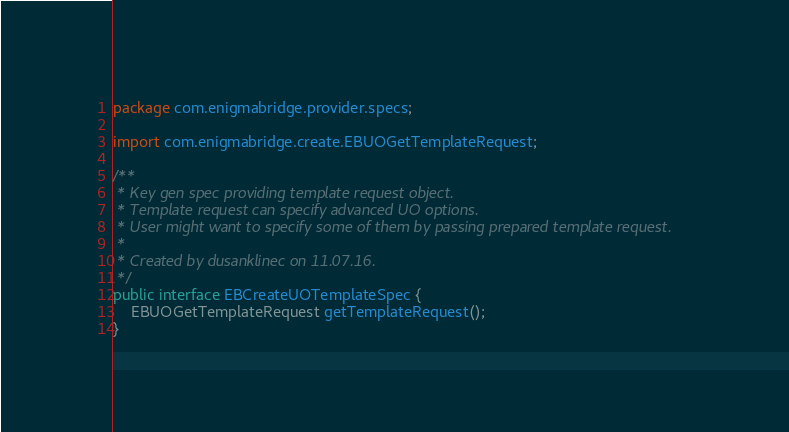<code> <loc_0><loc_0><loc_500><loc_500><_Java_>package com.enigmabridge.provider.specs;

import com.enigmabridge.create.EBUOGetTemplateRequest;

/**
 * Key gen spec providing template request object.
 * Template request can specify advanced UO options.
 * User might want to specify some of them by passing prepared template request.
 *
 * Created by dusanklinec on 11.07.16.
 */
public interface EBCreateUOTemplateSpec {
    EBUOGetTemplateRequest getTemplateRequest();
}
</code> 